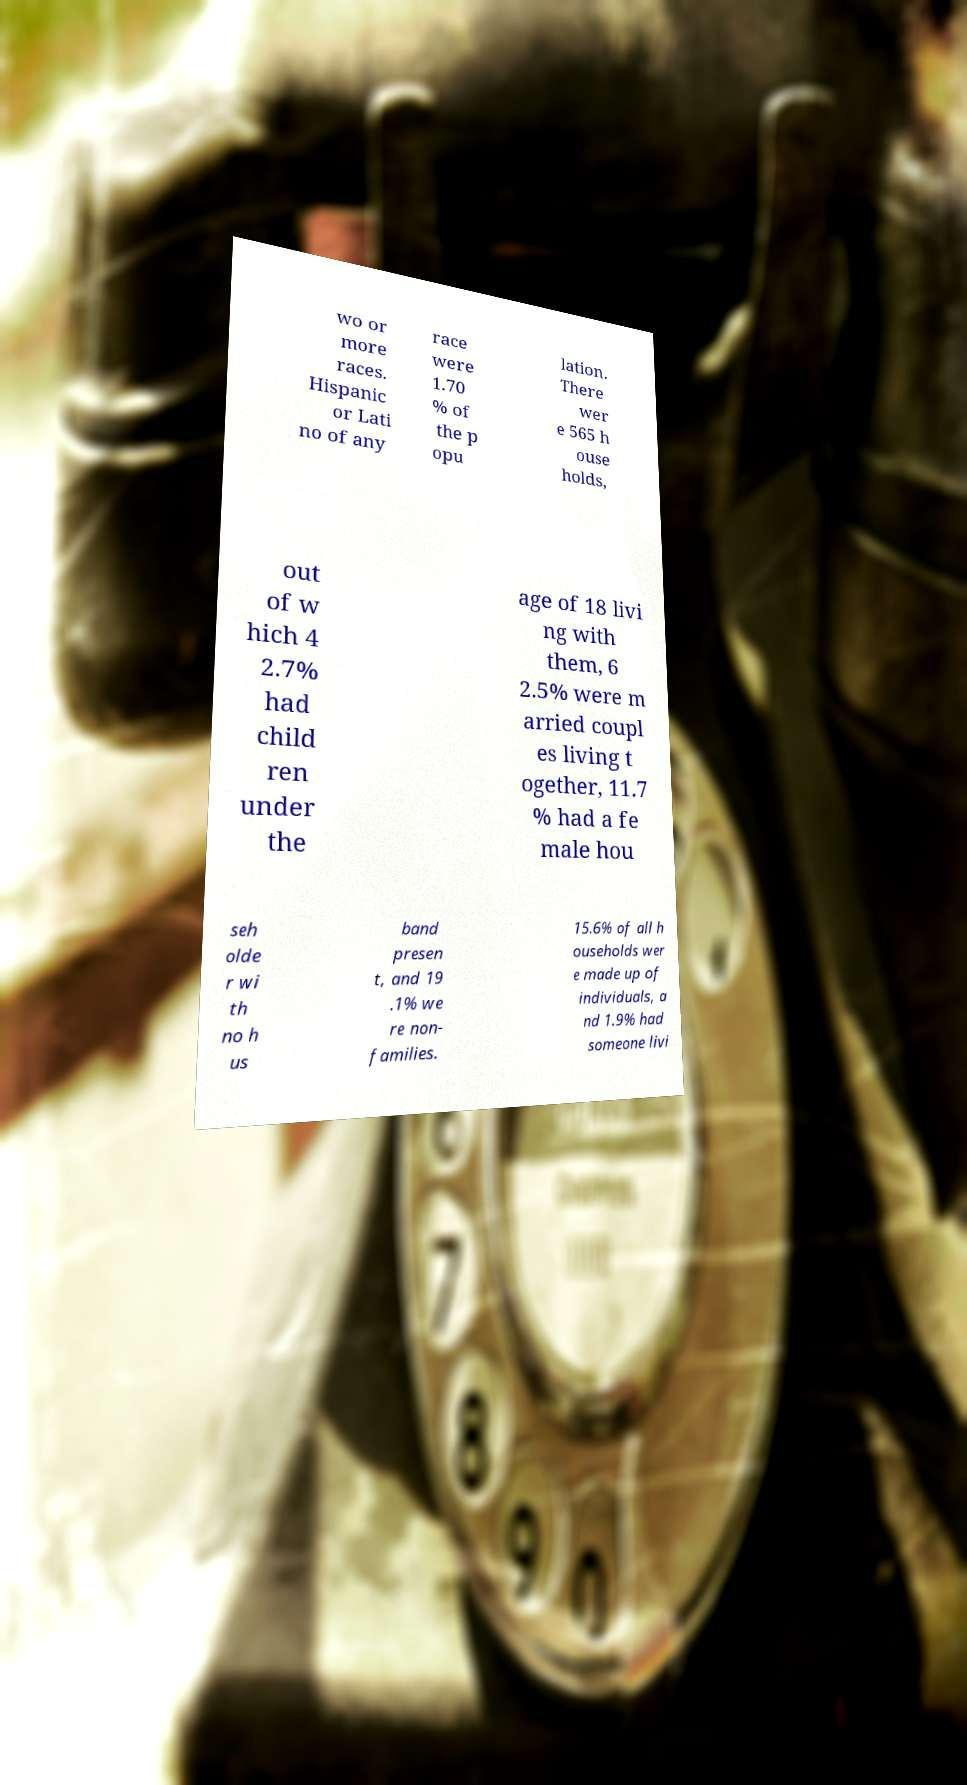Please identify and transcribe the text found in this image. wo or more races. Hispanic or Lati no of any race were 1.70 % of the p opu lation. There wer e 565 h ouse holds, out of w hich 4 2.7% had child ren under the age of 18 livi ng with them, 6 2.5% were m arried coupl es living t ogether, 11.7 % had a fe male hou seh olde r wi th no h us band presen t, and 19 .1% we re non- families. 15.6% of all h ouseholds wer e made up of individuals, a nd 1.9% had someone livi 